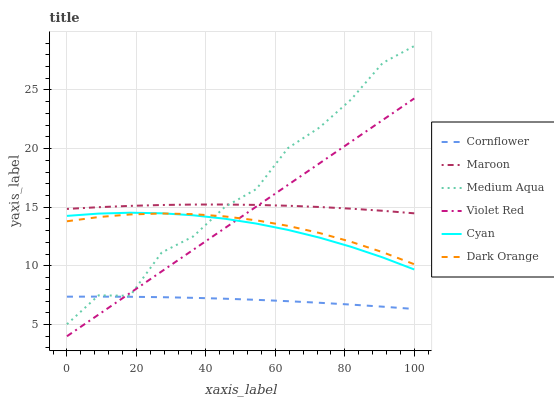Does Violet Red have the minimum area under the curve?
Answer yes or no. No. Does Violet Red have the maximum area under the curve?
Answer yes or no. No. Is Cornflower the smoothest?
Answer yes or no. No. Is Cornflower the roughest?
Answer yes or no. No. Does Cornflower have the lowest value?
Answer yes or no. No. Does Violet Red have the highest value?
Answer yes or no. No. Is Cornflower less than Cyan?
Answer yes or no. Yes. Is Dark Orange greater than Cornflower?
Answer yes or no. Yes. Does Cornflower intersect Cyan?
Answer yes or no. No. 